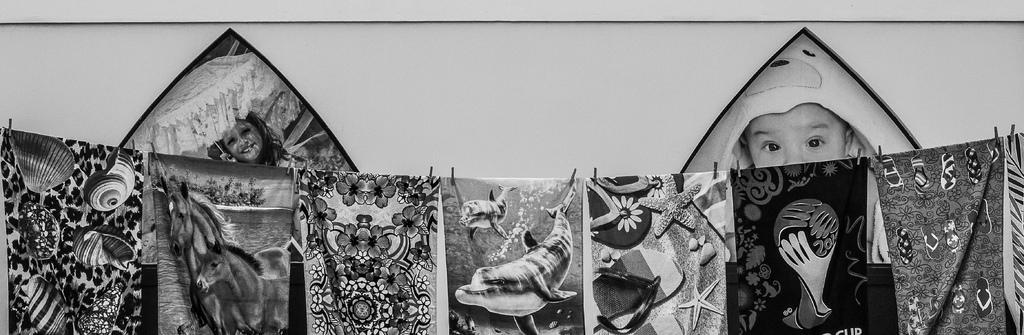What is hanging on the rope with clips in the image? There is a bed sheet hanging on the rope with clips in the image. What can be seen in the background of the image? There is a wall in the background of the image. What is displayed on the wall? There are two baby photos on the wall, one on each side. What is the color scheme of the image? The image is in black and white. How many nerves are visible in the image? There are no nerves visible in the image; it features a bed sheet hanging on a rope with clips, a wall with baby photos, and a black and white color scheme. What type of mice can be seen playing in the image? There are no mice present in the image. 